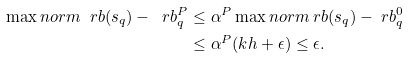<formula> <loc_0><loc_0><loc_500><loc_500>\max n o r m { \ r b ( s _ { q } ) - \ r b ^ { P } _ { q } } & \leq \alpha ^ { P } \max n o r m { \ r b ( s _ { q } ) - \ r b ^ { 0 } _ { q } } \\ & \leq \alpha ^ { P } ( k h + \epsilon ) \leq \epsilon .</formula> 